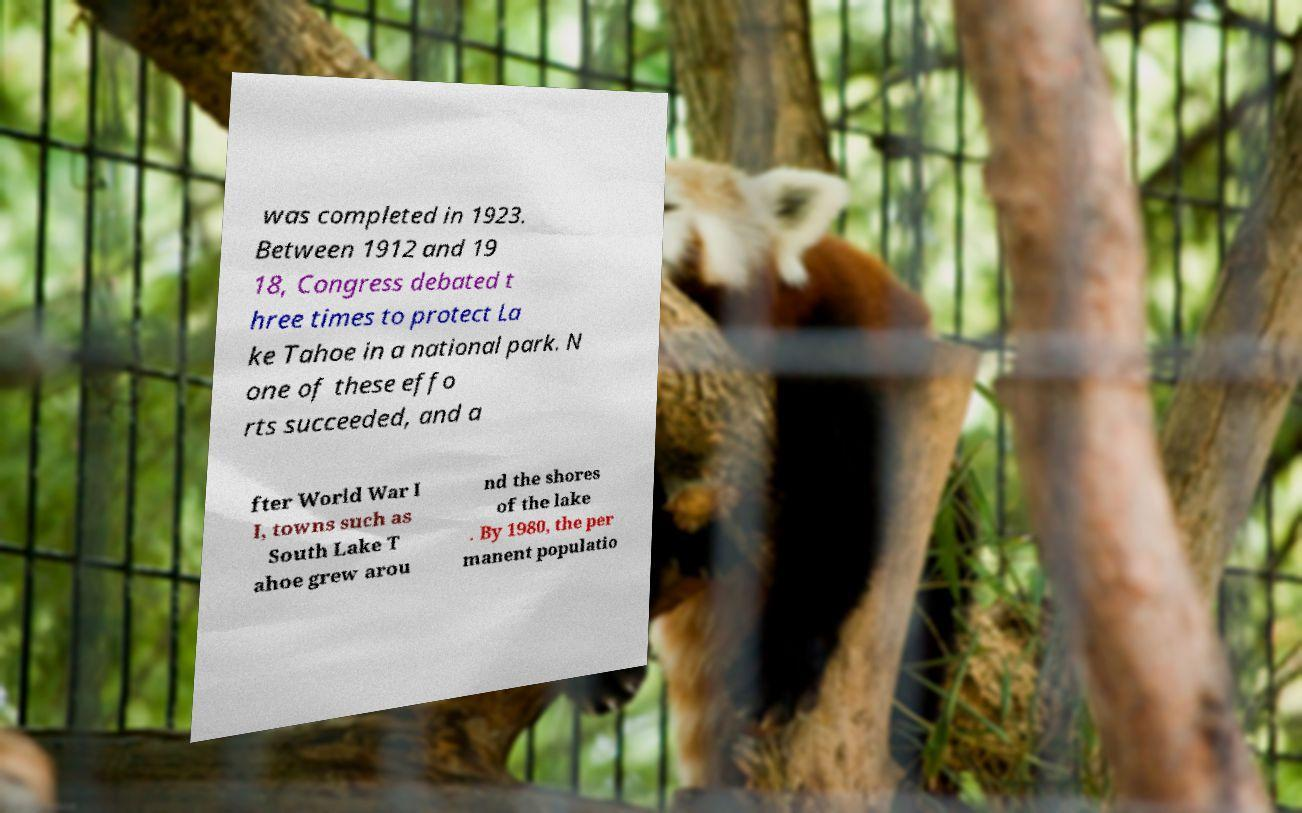What messages or text are displayed in this image? I need them in a readable, typed format. was completed in 1923. Between 1912 and 19 18, Congress debated t hree times to protect La ke Tahoe in a national park. N one of these effo rts succeeded, and a fter World War I I, towns such as South Lake T ahoe grew arou nd the shores of the lake . By 1980, the per manent populatio 